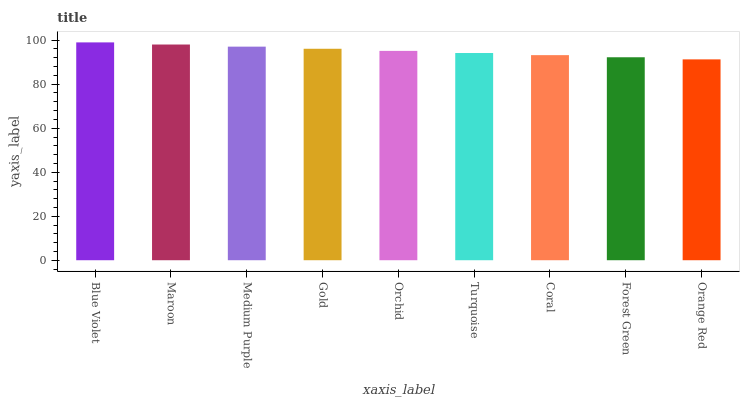Is Orange Red the minimum?
Answer yes or no. Yes. Is Blue Violet the maximum?
Answer yes or no. Yes. Is Maroon the minimum?
Answer yes or no. No. Is Maroon the maximum?
Answer yes or no. No. Is Blue Violet greater than Maroon?
Answer yes or no. Yes. Is Maroon less than Blue Violet?
Answer yes or no. Yes. Is Maroon greater than Blue Violet?
Answer yes or no. No. Is Blue Violet less than Maroon?
Answer yes or no. No. Is Orchid the high median?
Answer yes or no. Yes. Is Orchid the low median?
Answer yes or no. Yes. Is Gold the high median?
Answer yes or no. No. Is Orange Red the low median?
Answer yes or no. No. 